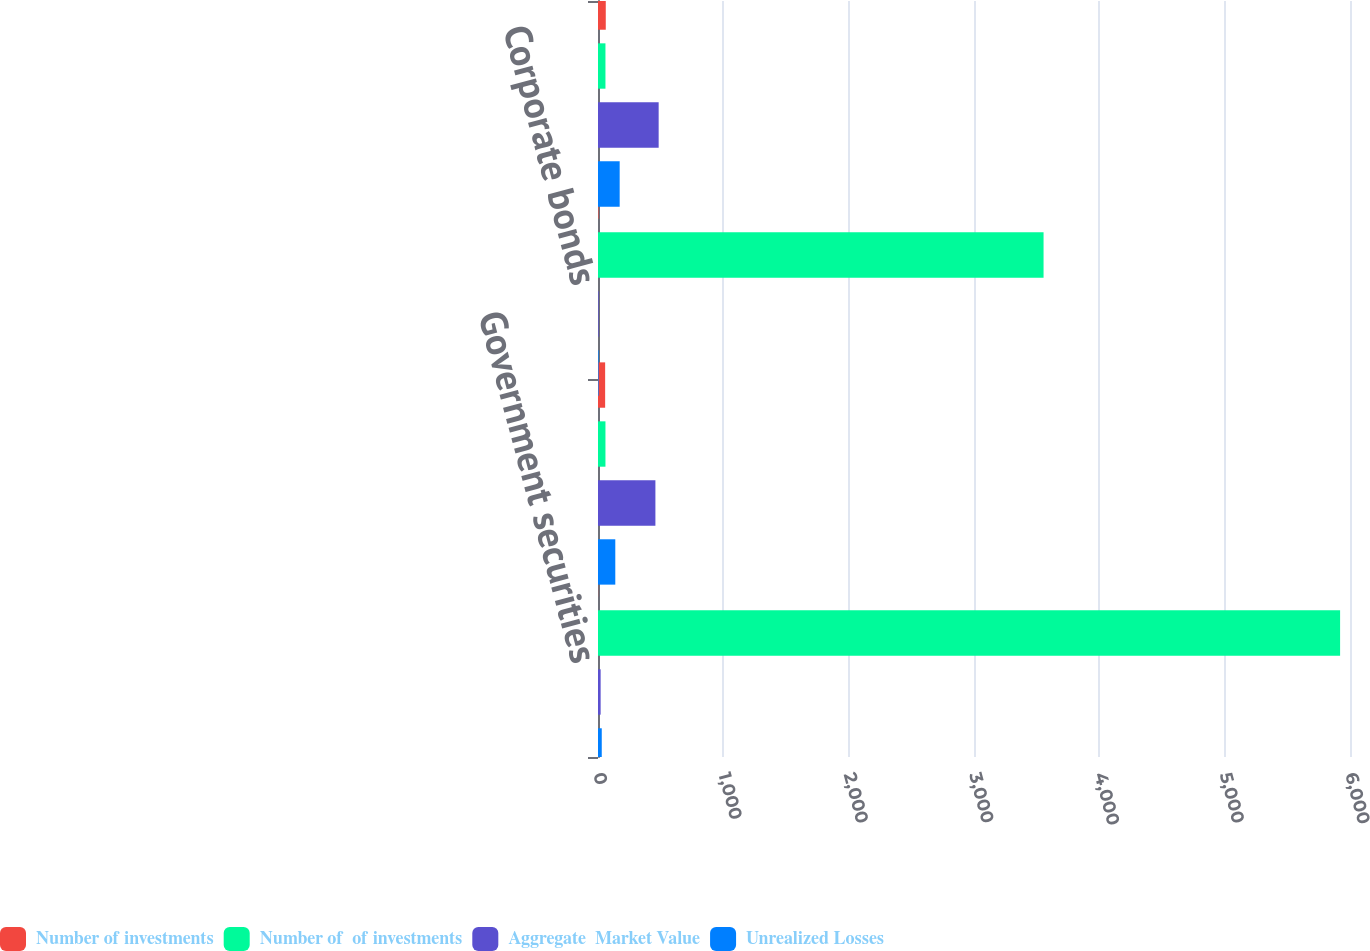Convert chart. <chart><loc_0><loc_0><loc_500><loc_500><stacked_bar_chart><ecel><fcel>Government securities<fcel>State and municipal bonds<fcel>Corporate bonds<fcel>Total<nl><fcel>Number of investments<fcel>1<fcel>57<fcel>4<fcel>62<nl><fcel>Number of  of investments<fcel>5921<fcel>59.5<fcel>3555<fcel>59.5<nl><fcel>Aggregate  Market Value<fcel>21<fcel>458<fcel>5<fcel>484<nl><fcel>Unrealized Losses<fcel>30<fcel>138<fcel>5<fcel>173<nl></chart> 